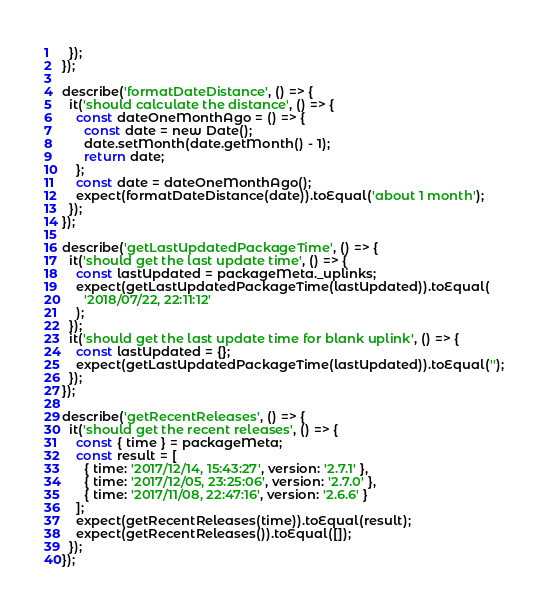<code> <loc_0><loc_0><loc_500><loc_500><_JavaScript_>  });
});

describe('formatDateDistance', () => {
  it('should calculate the distance', () => {
    const dateOneMonthAgo = () => {
      const date = new Date();
      date.setMonth(date.getMonth() - 1);
      return date;
    };
    const date = dateOneMonthAgo();
    expect(formatDateDistance(date)).toEqual('about 1 month');
  });
});

describe('getLastUpdatedPackageTime', () => {
  it('should get the last update time', () => {
    const lastUpdated = packageMeta._uplinks;
    expect(getLastUpdatedPackageTime(lastUpdated)).toEqual(
      '2018/07/22, 22:11:12'
    );
  });
  it('should get the last update time for blank uplink', () => {
    const lastUpdated = {};
    expect(getLastUpdatedPackageTime(lastUpdated)).toEqual('');
  });
});

describe('getRecentReleases', () => {
  it('should get the recent releases', () => {
    const { time } = packageMeta;
    const result = [
      { time: '2017/12/14, 15:43:27', version: '2.7.1' },
      { time: '2017/12/05, 23:25:06', version: '2.7.0' },
      { time: '2017/11/08, 22:47:16', version: '2.6.6' }
    ];
    expect(getRecentReleases(time)).toEqual(result);
    expect(getRecentReleases()).toEqual([]);
  });
});
</code> 